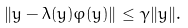<formula> <loc_0><loc_0><loc_500><loc_500>\| y - \lambda ( y ) \varphi ( y ) \| \leq \gamma \| y \| .</formula> 